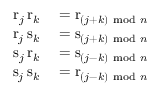<formula> <loc_0><loc_0><loc_500><loc_500>\begin{array} { r l } { r _ { j } \, r _ { k } } & = r _ { ( j + k ) { m o d } n } } \\ { r _ { j } \, s _ { k } } & = s _ { ( j + k ) { m o d } n } } \\ { s _ { j } \, r _ { k } } & = s _ { ( j - k ) { m o d } n } } \\ { s _ { j } \, s _ { k } } & = r _ { ( j - k ) { m o d } n } } \end{array}</formula> 